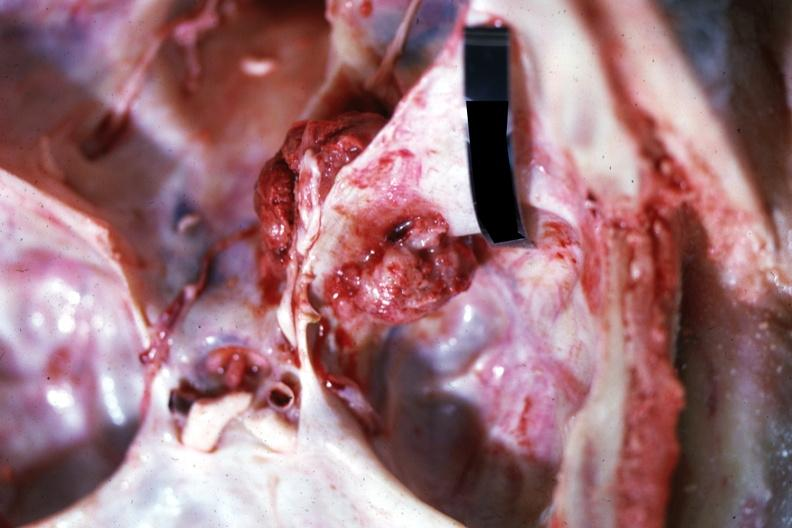does this image show close-up view of meaty appearing metastatic lesion in temporal and posterior fossa?
Answer the question using a single word or phrase. Yes 